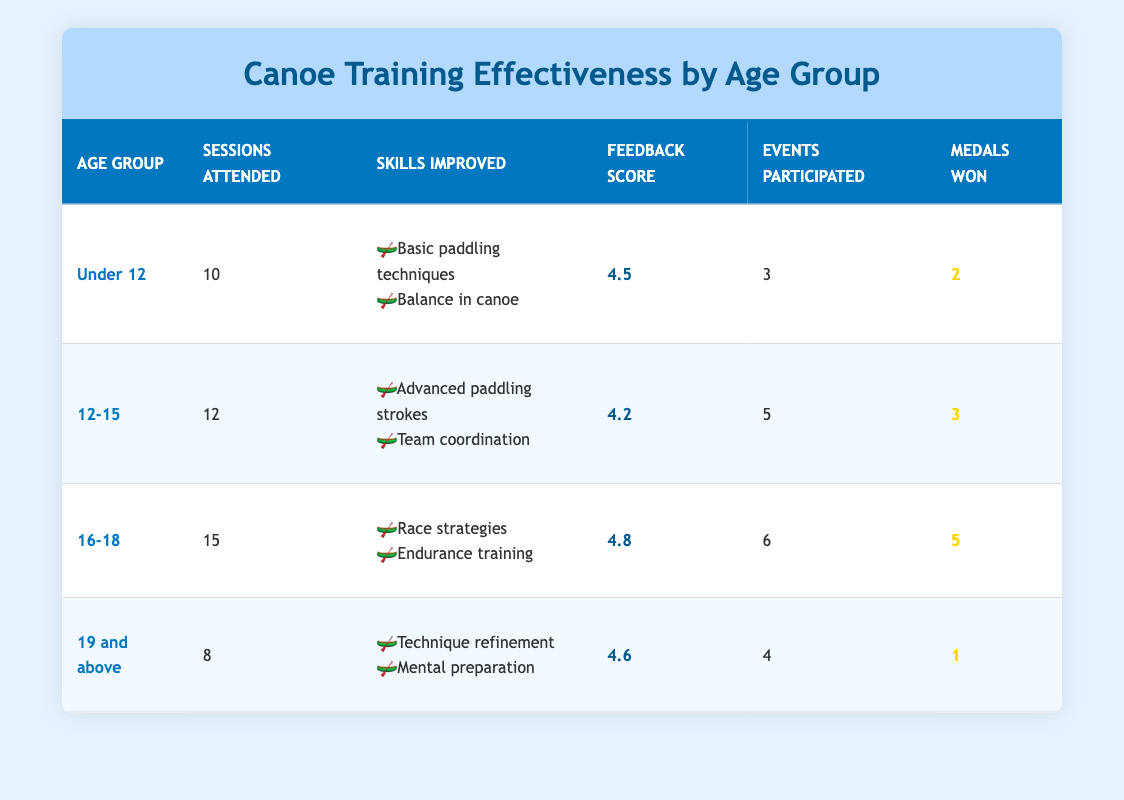What is the feedback score for the age group 16-18? According to the table, the feedback score for the age group 16-18 is listed directly in the feedback score column. It indicates that participants in this age group rated their training experience a score of 4.8.
Answer: 4.8 How many medals were won by the Under 12 age group? The table specifies that the Under 12 age group won a total of 2 medals, shown in the medals won column. This information can be retrieved directly from the table.
Answer: 2 What is the total number of sessions attended by all age groups? To find the total sessions attended, we add together the sessions for each age group: 10 (Under 12) + 12 (12-15) + 15 (16-18) + 8 (19 and above) = 45 sessions. Thus, the total sessions attended by all age groups is 45.
Answer: 45 Is the feedback score in the age group 12-15 greater than that in the age group 19 and above? The feedback score for the 12-15 age group is 4.2 and for 19 and above is 4.6. Since 4.2 is less than 4.6, we conclude that the statement is false.
Answer: No Which age group had the highest performance in terms of medals won? By looking at the medals won column, we compare the counts: Under 12 won 2, 12-15 won 3, 16-18 won 5, and 19 and above won 1. The age group 16-18 won the most medals, totaling 5, making it the highest performing age group.
Answer: 16-18 What is the average feedback score of all age groups? To find the average feedback score, we first add the feedback scores: 4.5 (Under 12) + 4.2 (12-15) + 4.8 (16-18) + 4.6 (19 and above) = 18.1. There are 4 age groups. Therefore, we divide the total score by the number of groups: 18.1 / 4 = 4.525. The average feedback score is 4.525.
Answer: 4.525 How many events did the 19 and above age group participate in? The table directly shows that the 19 and above age group participated in 4 events, which is stated in the events participated column. There’s no further calculation needed to answer this question.
Answer: 4 Do all age groups have more than 5 sessions attended? Looking at the sessions attended column, we see the following: Under 12 has 10, 12-15 has 12, 16-18 has 15, and 19 and above has 8. Since the age group 19 and above only attended 8 sessions, which is not more than 5, we conclude that not all age groups meet the criterion.
Answer: No 